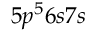Convert formula to latex. <formula><loc_0><loc_0><loc_500><loc_500>5 p ^ { 5 } 6 s 7 s</formula> 